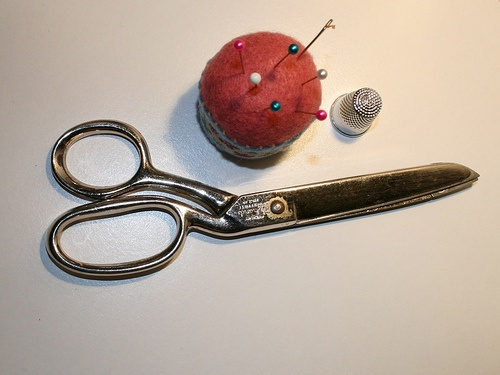Describe the objects in this image and their specific colors. I can see scissors in darkgray, black, lightgray, and gray tones in this image. 